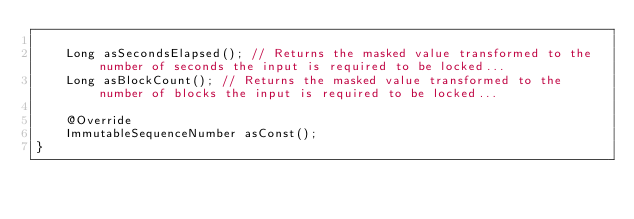<code> <loc_0><loc_0><loc_500><loc_500><_Java_>
    Long asSecondsElapsed(); // Returns the masked value transformed to the number of seconds the input is required to be locked...
    Long asBlockCount(); // Returns the masked value transformed to the number of blocks the input is required to be locked...

    @Override
    ImmutableSequenceNumber asConst();
}
</code> 